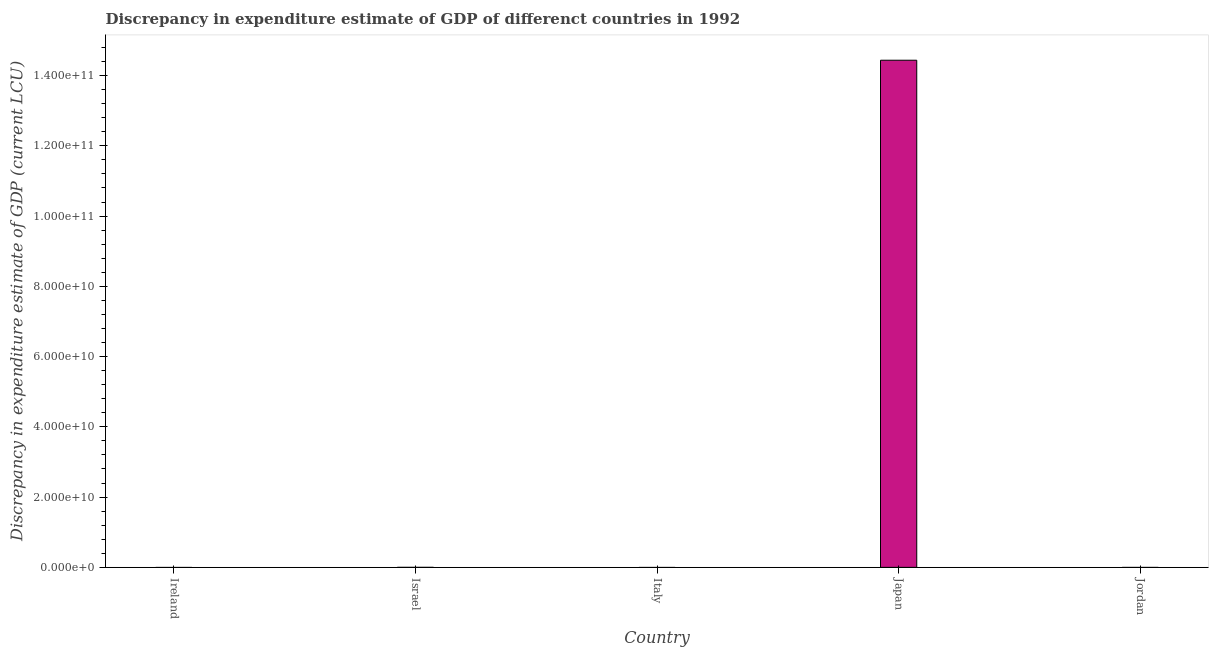Does the graph contain any zero values?
Provide a succinct answer. Yes. Does the graph contain grids?
Make the answer very short. No. What is the title of the graph?
Give a very brief answer. Discrepancy in expenditure estimate of GDP of differenct countries in 1992. What is the label or title of the Y-axis?
Offer a very short reply. Discrepancy in expenditure estimate of GDP (current LCU). Across all countries, what is the maximum discrepancy in expenditure estimate of gdp?
Give a very brief answer. 1.44e+11. Across all countries, what is the minimum discrepancy in expenditure estimate of gdp?
Provide a short and direct response. 0. What is the sum of the discrepancy in expenditure estimate of gdp?
Your response must be concise. 1.44e+11. What is the average discrepancy in expenditure estimate of gdp per country?
Your answer should be compact. 2.89e+1. What is the median discrepancy in expenditure estimate of gdp?
Your response must be concise. 0. What is the difference between the highest and the lowest discrepancy in expenditure estimate of gdp?
Your response must be concise. 1.44e+11. Are all the bars in the graph horizontal?
Provide a succinct answer. No. What is the Discrepancy in expenditure estimate of GDP (current LCU) of Ireland?
Give a very brief answer. 0. What is the Discrepancy in expenditure estimate of GDP (current LCU) of Italy?
Keep it short and to the point. 0. What is the Discrepancy in expenditure estimate of GDP (current LCU) of Japan?
Give a very brief answer. 1.44e+11. What is the Discrepancy in expenditure estimate of GDP (current LCU) of Jordan?
Make the answer very short. 0. 